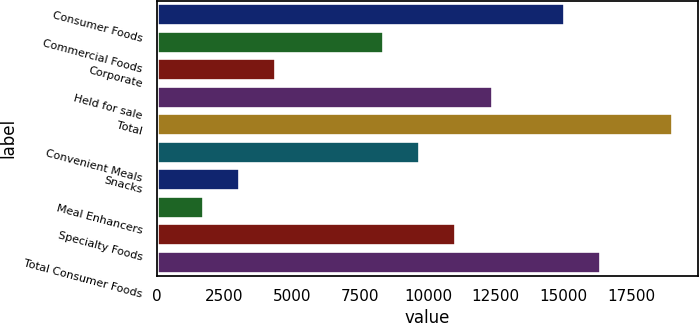<chart> <loc_0><loc_0><loc_500><loc_500><bar_chart><fcel>Consumer Foods<fcel>Commercial Foods<fcel>Corporate<fcel>Held for sale<fcel>Total<fcel>Convenient Meals<fcel>Snacks<fcel>Meal Enhancers<fcel>Specialty Foods<fcel>Total Consumer Foods<nl><fcel>15014.9<fcel>8353.06<fcel>4355.98<fcel>12350.1<fcel>19011.9<fcel>9685.42<fcel>3023.62<fcel>1691.26<fcel>11017.8<fcel>16347.2<nl></chart> 